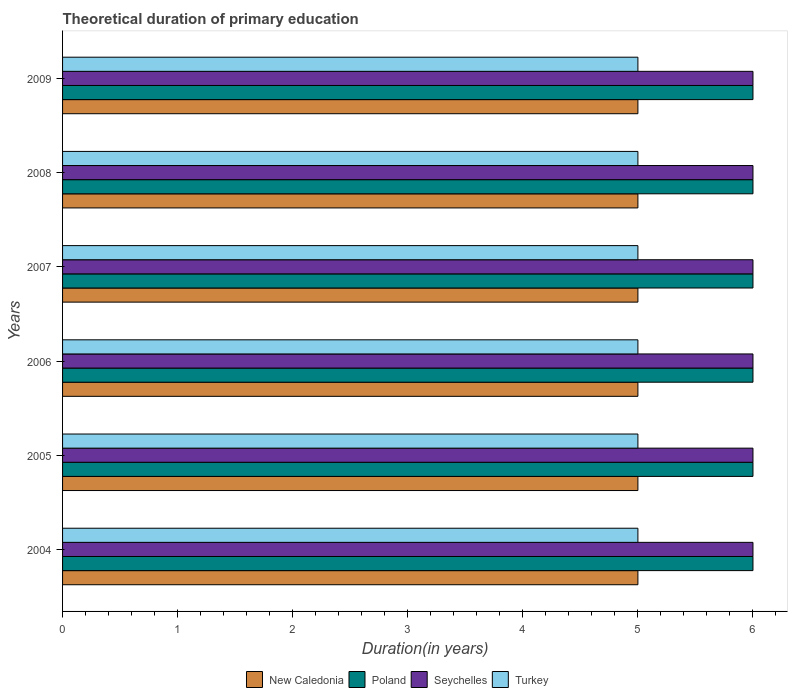How many groups of bars are there?
Keep it short and to the point. 6. Are the number of bars per tick equal to the number of legend labels?
Your answer should be compact. Yes. How many bars are there on the 1st tick from the top?
Provide a short and direct response. 4. How many bars are there on the 3rd tick from the bottom?
Give a very brief answer. 4. What is the label of the 1st group of bars from the top?
Your answer should be compact. 2009. In how many cases, is the number of bars for a given year not equal to the number of legend labels?
Offer a very short reply. 0. What is the total theoretical duration of primary education in Turkey in 2006?
Provide a short and direct response. 5. In which year was the total theoretical duration of primary education in Poland minimum?
Ensure brevity in your answer.  2004. What is the total total theoretical duration of primary education in Turkey in the graph?
Offer a very short reply. 30. What is the difference between the total theoretical duration of primary education in New Caledonia in 2004 and that in 2006?
Make the answer very short. 0. What is the difference between the total theoretical duration of primary education in Poland in 2005 and the total theoretical duration of primary education in Turkey in 2008?
Ensure brevity in your answer.  1. In how many years, is the total theoretical duration of primary education in Turkey greater than the average total theoretical duration of primary education in Turkey taken over all years?
Your response must be concise. 0. Is it the case that in every year, the sum of the total theoretical duration of primary education in New Caledonia and total theoretical duration of primary education in Turkey is greater than the sum of total theoretical duration of primary education in Seychelles and total theoretical duration of primary education in Poland?
Keep it short and to the point. No. What does the 2nd bar from the top in 2007 represents?
Offer a very short reply. Seychelles. What does the 1st bar from the bottom in 2005 represents?
Make the answer very short. New Caledonia. Is it the case that in every year, the sum of the total theoretical duration of primary education in Seychelles and total theoretical duration of primary education in Poland is greater than the total theoretical duration of primary education in Turkey?
Provide a succinct answer. Yes. How many bars are there?
Give a very brief answer. 24. Are all the bars in the graph horizontal?
Provide a succinct answer. Yes. What is the difference between two consecutive major ticks on the X-axis?
Offer a terse response. 1. Are the values on the major ticks of X-axis written in scientific E-notation?
Your answer should be compact. No. Does the graph contain grids?
Provide a short and direct response. No. How are the legend labels stacked?
Your response must be concise. Horizontal. What is the title of the graph?
Make the answer very short. Theoretical duration of primary education. What is the label or title of the X-axis?
Your answer should be very brief. Duration(in years). What is the Duration(in years) of Turkey in 2004?
Give a very brief answer. 5. What is the Duration(in years) in Poland in 2005?
Ensure brevity in your answer.  6. What is the Duration(in years) in New Caledonia in 2006?
Keep it short and to the point. 5. What is the Duration(in years) in Poland in 2006?
Ensure brevity in your answer.  6. What is the Duration(in years) in Seychelles in 2006?
Offer a terse response. 6. What is the Duration(in years) in Turkey in 2006?
Offer a terse response. 5. What is the Duration(in years) of Poland in 2007?
Give a very brief answer. 6. What is the Duration(in years) of Seychelles in 2007?
Offer a terse response. 6. What is the Duration(in years) in Turkey in 2007?
Your answer should be very brief. 5. What is the Duration(in years) in Poland in 2008?
Give a very brief answer. 6. What is the Duration(in years) in Seychelles in 2008?
Give a very brief answer. 6. What is the Duration(in years) in Turkey in 2008?
Offer a terse response. 5. What is the Duration(in years) of Seychelles in 2009?
Your answer should be compact. 6. What is the Duration(in years) in Turkey in 2009?
Make the answer very short. 5. Across all years, what is the maximum Duration(in years) of Seychelles?
Your answer should be very brief. 6. Across all years, what is the maximum Duration(in years) in Turkey?
Ensure brevity in your answer.  5. Across all years, what is the minimum Duration(in years) in New Caledonia?
Keep it short and to the point. 5. Across all years, what is the minimum Duration(in years) in Seychelles?
Give a very brief answer. 6. Across all years, what is the minimum Duration(in years) in Turkey?
Make the answer very short. 5. What is the difference between the Duration(in years) of New Caledonia in 2004 and that in 2006?
Give a very brief answer. 0. What is the difference between the Duration(in years) in Poland in 2004 and that in 2006?
Give a very brief answer. 0. What is the difference between the Duration(in years) in Seychelles in 2004 and that in 2006?
Offer a terse response. 0. What is the difference between the Duration(in years) of Seychelles in 2004 and that in 2007?
Ensure brevity in your answer.  0. What is the difference between the Duration(in years) of Turkey in 2004 and that in 2007?
Offer a terse response. 0. What is the difference between the Duration(in years) of New Caledonia in 2004 and that in 2009?
Provide a succinct answer. 0. What is the difference between the Duration(in years) of Poland in 2004 and that in 2009?
Offer a terse response. 0. What is the difference between the Duration(in years) of Turkey in 2004 and that in 2009?
Your answer should be compact. 0. What is the difference between the Duration(in years) of Poland in 2005 and that in 2006?
Provide a short and direct response. 0. What is the difference between the Duration(in years) in Turkey in 2005 and that in 2006?
Make the answer very short. 0. What is the difference between the Duration(in years) of New Caledonia in 2005 and that in 2007?
Your answer should be very brief. 0. What is the difference between the Duration(in years) of Seychelles in 2005 and that in 2007?
Your answer should be very brief. 0. What is the difference between the Duration(in years) of Turkey in 2005 and that in 2007?
Offer a terse response. 0. What is the difference between the Duration(in years) in Seychelles in 2005 and that in 2008?
Ensure brevity in your answer.  0. What is the difference between the Duration(in years) in Turkey in 2005 and that in 2008?
Offer a very short reply. 0. What is the difference between the Duration(in years) in New Caledonia in 2006 and that in 2007?
Make the answer very short. 0. What is the difference between the Duration(in years) of Poland in 2006 and that in 2008?
Your answer should be very brief. 0. What is the difference between the Duration(in years) of Seychelles in 2006 and that in 2008?
Your answer should be very brief. 0. What is the difference between the Duration(in years) in New Caledonia in 2006 and that in 2009?
Provide a succinct answer. 0. What is the difference between the Duration(in years) of Seychelles in 2006 and that in 2009?
Provide a succinct answer. 0. What is the difference between the Duration(in years) of Poland in 2007 and that in 2008?
Provide a succinct answer. 0. What is the difference between the Duration(in years) in Seychelles in 2007 and that in 2008?
Provide a short and direct response. 0. What is the difference between the Duration(in years) in Poland in 2007 and that in 2009?
Your answer should be very brief. 0. What is the difference between the Duration(in years) in Turkey in 2007 and that in 2009?
Provide a short and direct response. 0. What is the difference between the Duration(in years) of New Caledonia in 2008 and that in 2009?
Keep it short and to the point. 0. What is the difference between the Duration(in years) of New Caledonia in 2004 and the Duration(in years) of Turkey in 2005?
Provide a short and direct response. 0. What is the difference between the Duration(in years) of Poland in 2004 and the Duration(in years) of Turkey in 2005?
Your answer should be compact. 1. What is the difference between the Duration(in years) of New Caledonia in 2004 and the Duration(in years) of Poland in 2006?
Ensure brevity in your answer.  -1. What is the difference between the Duration(in years) in New Caledonia in 2004 and the Duration(in years) in Turkey in 2006?
Your response must be concise. 0. What is the difference between the Duration(in years) of Seychelles in 2004 and the Duration(in years) of Turkey in 2006?
Your answer should be compact. 1. What is the difference between the Duration(in years) in New Caledonia in 2004 and the Duration(in years) in Poland in 2007?
Your answer should be compact. -1. What is the difference between the Duration(in years) in New Caledonia in 2004 and the Duration(in years) in Turkey in 2007?
Give a very brief answer. 0. What is the difference between the Duration(in years) of New Caledonia in 2004 and the Duration(in years) of Poland in 2008?
Offer a very short reply. -1. What is the difference between the Duration(in years) of Poland in 2004 and the Duration(in years) of Turkey in 2008?
Offer a very short reply. 1. What is the difference between the Duration(in years) in New Caledonia in 2004 and the Duration(in years) in Seychelles in 2009?
Your response must be concise. -1. What is the difference between the Duration(in years) in New Caledonia in 2004 and the Duration(in years) in Turkey in 2009?
Make the answer very short. 0. What is the difference between the Duration(in years) in Poland in 2004 and the Duration(in years) in Turkey in 2009?
Your answer should be very brief. 1. What is the difference between the Duration(in years) in Seychelles in 2004 and the Duration(in years) in Turkey in 2009?
Give a very brief answer. 1. What is the difference between the Duration(in years) in New Caledonia in 2005 and the Duration(in years) in Turkey in 2006?
Offer a very short reply. 0. What is the difference between the Duration(in years) in Poland in 2005 and the Duration(in years) in Seychelles in 2006?
Offer a very short reply. 0. What is the difference between the Duration(in years) in Poland in 2005 and the Duration(in years) in Turkey in 2006?
Your answer should be compact. 1. What is the difference between the Duration(in years) in New Caledonia in 2005 and the Duration(in years) in Poland in 2007?
Your answer should be very brief. -1. What is the difference between the Duration(in years) in New Caledonia in 2005 and the Duration(in years) in Seychelles in 2007?
Give a very brief answer. -1. What is the difference between the Duration(in years) of Poland in 2005 and the Duration(in years) of Turkey in 2007?
Provide a short and direct response. 1. What is the difference between the Duration(in years) of New Caledonia in 2005 and the Duration(in years) of Poland in 2008?
Provide a short and direct response. -1. What is the difference between the Duration(in years) of Poland in 2005 and the Duration(in years) of Seychelles in 2008?
Make the answer very short. 0. What is the difference between the Duration(in years) of Poland in 2005 and the Duration(in years) of Turkey in 2008?
Make the answer very short. 1. What is the difference between the Duration(in years) of Poland in 2005 and the Duration(in years) of Seychelles in 2009?
Your response must be concise. 0. What is the difference between the Duration(in years) in Poland in 2005 and the Duration(in years) in Turkey in 2009?
Offer a terse response. 1. What is the difference between the Duration(in years) in Seychelles in 2005 and the Duration(in years) in Turkey in 2009?
Provide a succinct answer. 1. What is the difference between the Duration(in years) in New Caledonia in 2006 and the Duration(in years) in Poland in 2007?
Your answer should be very brief. -1. What is the difference between the Duration(in years) of New Caledonia in 2006 and the Duration(in years) of Seychelles in 2007?
Offer a very short reply. -1. What is the difference between the Duration(in years) of New Caledonia in 2006 and the Duration(in years) of Turkey in 2007?
Your response must be concise. 0. What is the difference between the Duration(in years) of Poland in 2006 and the Duration(in years) of Seychelles in 2007?
Keep it short and to the point. 0. What is the difference between the Duration(in years) of Poland in 2006 and the Duration(in years) of Turkey in 2007?
Offer a terse response. 1. What is the difference between the Duration(in years) of Seychelles in 2006 and the Duration(in years) of Turkey in 2007?
Your answer should be very brief. 1. What is the difference between the Duration(in years) of New Caledonia in 2006 and the Duration(in years) of Seychelles in 2008?
Give a very brief answer. -1. What is the difference between the Duration(in years) of New Caledonia in 2006 and the Duration(in years) of Turkey in 2008?
Your answer should be very brief. 0. What is the difference between the Duration(in years) of Poland in 2006 and the Duration(in years) of Turkey in 2008?
Offer a very short reply. 1. What is the difference between the Duration(in years) in New Caledonia in 2006 and the Duration(in years) in Turkey in 2009?
Offer a terse response. 0. What is the difference between the Duration(in years) in Poland in 2006 and the Duration(in years) in Turkey in 2009?
Keep it short and to the point. 1. What is the difference between the Duration(in years) in New Caledonia in 2007 and the Duration(in years) in Seychelles in 2008?
Offer a terse response. -1. What is the difference between the Duration(in years) of Poland in 2007 and the Duration(in years) of Turkey in 2008?
Provide a succinct answer. 1. What is the difference between the Duration(in years) of Seychelles in 2007 and the Duration(in years) of Turkey in 2008?
Make the answer very short. 1. What is the difference between the Duration(in years) of Poland in 2007 and the Duration(in years) of Seychelles in 2009?
Offer a very short reply. 0. What is the difference between the Duration(in years) in Poland in 2007 and the Duration(in years) in Turkey in 2009?
Ensure brevity in your answer.  1. What is the difference between the Duration(in years) in Seychelles in 2007 and the Duration(in years) in Turkey in 2009?
Your response must be concise. 1. What is the difference between the Duration(in years) in New Caledonia in 2008 and the Duration(in years) in Poland in 2009?
Make the answer very short. -1. What is the difference between the Duration(in years) in New Caledonia in 2008 and the Duration(in years) in Seychelles in 2009?
Offer a terse response. -1. What is the difference between the Duration(in years) in New Caledonia in 2008 and the Duration(in years) in Turkey in 2009?
Your response must be concise. 0. What is the difference between the Duration(in years) in Poland in 2008 and the Duration(in years) in Turkey in 2009?
Offer a very short reply. 1. What is the average Duration(in years) of Poland per year?
Provide a succinct answer. 6. In the year 2004, what is the difference between the Duration(in years) in New Caledonia and Duration(in years) in Seychelles?
Ensure brevity in your answer.  -1. In the year 2004, what is the difference between the Duration(in years) in Seychelles and Duration(in years) in Turkey?
Make the answer very short. 1. In the year 2005, what is the difference between the Duration(in years) of Seychelles and Duration(in years) of Turkey?
Keep it short and to the point. 1. In the year 2006, what is the difference between the Duration(in years) of New Caledonia and Duration(in years) of Turkey?
Give a very brief answer. 0. In the year 2006, what is the difference between the Duration(in years) of Seychelles and Duration(in years) of Turkey?
Offer a very short reply. 1. In the year 2007, what is the difference between the Duration(in years) in New Caledonia and Duration(in years) in Poland?
Offer a terse response. -1. In the year 2007, what is the difference between the Duration(in years) of New Caledonia and Duration(in years) of Seychelles?
Keep it short and to the point. -1. In the year 2007, what is the difference between the Duration(in years) of New Caledonia and Duration(in years) of Turkey?
Provide a succinct answer. 0. In the year 2007, what is the difference between the Duration(in years) of Poland and Duration(in years) of Seychelles?
Ensure brevity in your answer.  0. In the year 2007, what is the difference between the Duration(in years) in Poland and Duration(in years) in Turkey?
Offer a very short reply. 1. In the year 2007, what is the difference between the Duration(in years) of Seychelles and Duration(in years) of Turkey?
Ensure brevity in your answer.  1. In the year 2008, what is the difference between the Duration(in years) of New Caledonia and Duration(in years) of Turkey?
Your response must be concise. 0. In the year 2009, what is the difference between the Duration(in years) of New Caledonia and Duration(in years) of Turkey?
Provide a succinct answer. 0. What is the ratio of the Duration(in years) in Poland in 2004 to that in 2005?
Offer a terse response. 1. What is the ratio of the Duration(in years) in Seychelles in 2004 to that in 2005?
Provide a succinct answer. 1. What is the ratio of the Duration(in years) in New Caledonia in 2004 to that in 2006?
Offer a terse response. 1. What is the ratio of the Duration(in years) in Seychelles in 2004 to that in 2006?
Your answer should be compact. 1. What is the ratio of the Duration(in years) in Poland in 2004 to that in 2007?
Your answer should be very brief. 1. What is the ratio of the Duration(in years) in Seychelles in 2004 to that in 2007?
Your answer should be compact. 1. What is the ratio of the Duration(in years) of Poland in 2004 to that in 2008?
Make the answer very short. 1. What is the ratio of the Duration(in years) in Seychelles in 2004 to that in 2008?
Give a very brief answer. 1. What is the ratio of the Duration(in years) of Turkey in 2004 to that in 2008?
Offer a terse response. 1. What is the ratio of the Duration(in years) in Seychelles in 2004 to that in 2009?
Provide a short and direct response. 1. What is the ratio of the Duration(in years) of Turkey in 2004 to that in 2009?
Provide a succinct answer. 1. What is the ratio of the Duration(in years) in New Caledonia in 2005 to that in 2006?
Offer a terse response. 1. What is the ratio of the Duration(in years) in Poland in 2005 to that in 2006?
Give a very brief answer. 1. What is the ratio of the Duration(in years) in Seychelles in 2005 to that in 2006?
Provide a succinct answer. 1. What is the ratio of the Duration(in years) of Poland in 2005 to that in 2007?
Offer a terse response. 1. What is the ratio of the Duration(in years) of Turkey in 2005 to that in 2007?
Provide a succinct answer. 1. What is the ratio of the Duration(in years) in New Caledonia in 2005 to that in 2008?
Offer a very short reply. 1. What is the ratio of the Duration(in years) in Poland in 2005 to that in 2008?
Your answer should be very brief. 1. What is the ratio of the Duration(in years) of Seychelles in 2005 to that in 2008?
Keep it short and to the point. 1. What is the ratio of the Duration(in years) in Turkey in 2005 to that in 2008?
Provide a succinct answer. 1. What is the ratio of the Duration(in years) of New Caledonia in 2005 to that in 2009?
Your answer should be very brief. 1. What is the ratio of the Duration(in years) in Poland in 2005 to that in 2009?
Give a very brief answer. 1. What is the ratio of the Duration(in years) in Seychelles in 2005 to that in 2009?
Keep it short and to the point. 1. What is the ratio of the Duration(in years) of Seychelles in 2006 to that in 2007?
Give a very brief answer. 1. What is the ratio of the Duration(in years) in Poland in 2006 to that in 2008?
Provide a short and direct response. 1. What is the ratio of the Duration(in years) in New Caledonia in 2006 to that in 2009?
Ensure brevity in your answer.  1. What is the ratio of the Duration(in years) in Turkey in 2006 to that in 2009?
Offer a terse response. 1. What is the ratio of the Duration(in years) in New Caledonia in 2007 to that in 2008?
Provide a short and direct response. 1. What is the ratio of the Duration(in years) in Poland in 2007 to that in 2008?
Give a very brief answer. 1. What is the ratio of the Duration(in years) in New Caledonia in 2007 to that in 2009?
Your answer should be compact. 1. What is the ratio of the Duration(in years) of Poland in 2007 to that in 2009?
Ensure brevity in your answer.  1. What is the ratio of the Duration(in years) in Seychelles in 2007 to that in 2009?
Your answer should be compact. 1. What is the ratio of the Duration(in years) of Turkey in 2007 to that in 2009?
Your answer should be very brief. 1. What is the ratio of the Duration(in years) in Poland in 2008 to that in 2009?
Your response must be concise. 1. What is the difference between the highest and the second highest Duration(in years) of Seychelles?
Provide a short and direct response. 0. What is the difference between the highest and the second highest Duration(in years) of Turkey?
Offer a very short reply. 0. What is the difference between the highest and the lowest Duration(in years) in New Caledonia?
Your answer should be compact. 0. What is the difference between the highest and the lowest Duration(in years) of Poland?
Provide a short and direct response. 0. What is the difference between the highest and the lowest Duration(in years) of Seychelles?
Provide a succinct answer. 0. 